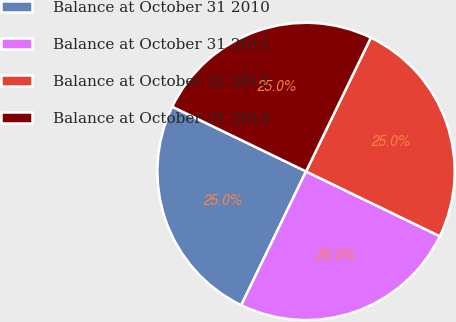Convert chart to OTSL. <chart><loc_0><loc_0><loc_500><loc_500><pie_chart><fcel>Balance at October 31 2010<fcel>Balance at October 31 2011<fcel>Balance at October 31 2012<fcel>Balance at October 31 2013<nl><fcel>24.99%<fcel>25.0%<fcel>25.0%<fcel>25.01%<nl></chart> 